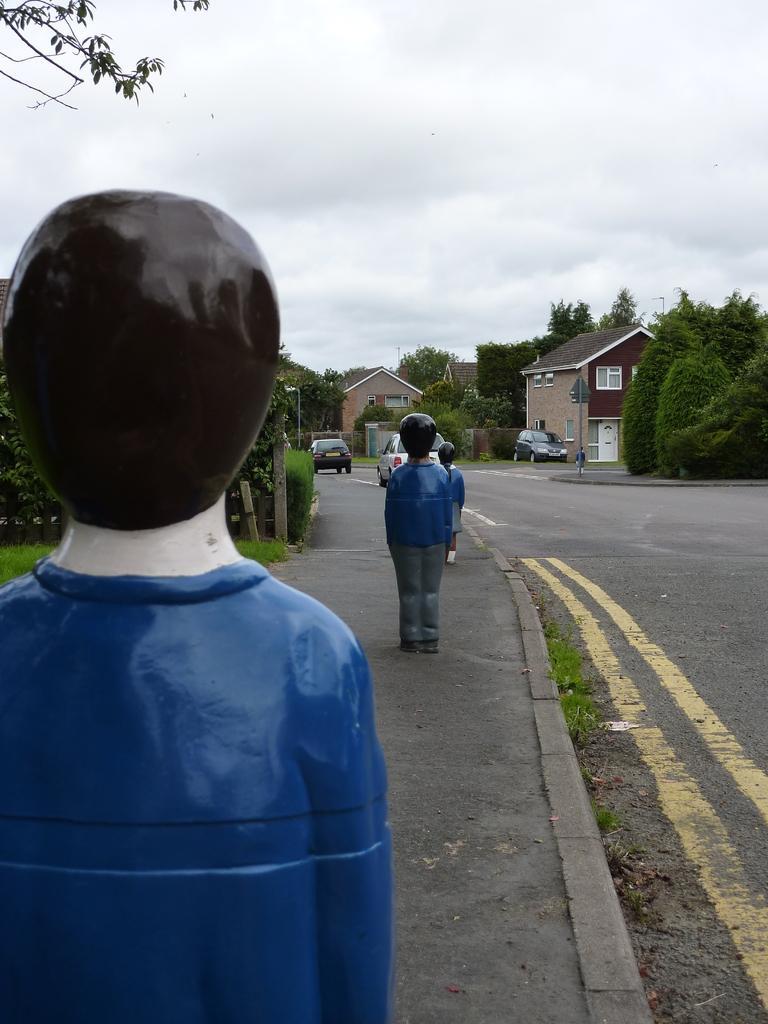How would you summarize this image in a sentence or two? In the center of the image there are depictions of persons on the pavement. To the right side of the image there is a road. There are houses,trees. At the top of the image there is sky and clouds. 